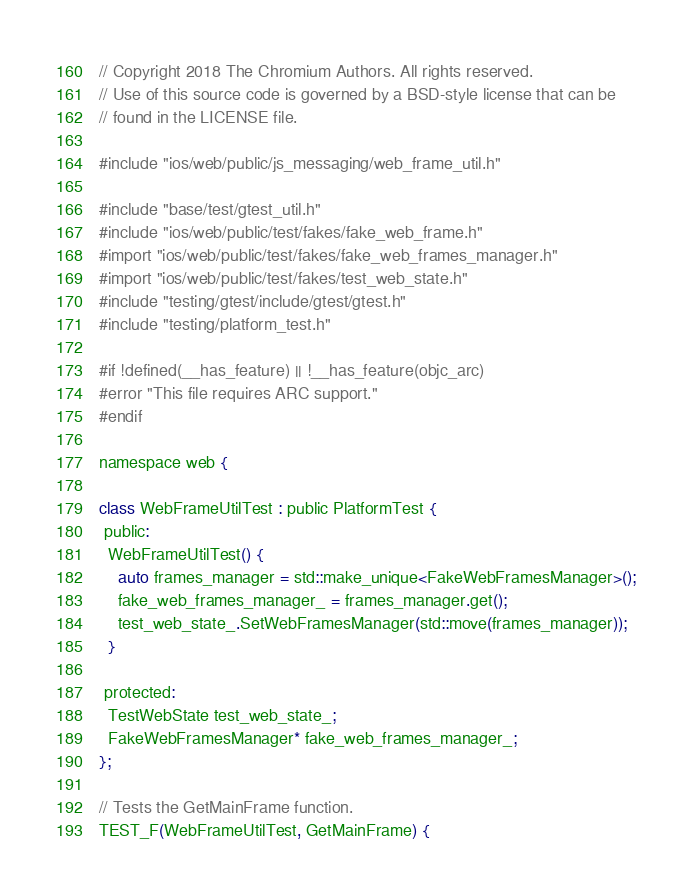Convert code to text. <code><loc_0><loc_0><loc_500><loc_500><_ObjectiveC_>// Copyright 2018 The Chromium Authors. All rights reserved.
// Use of this source code is governed by a BSD-style license that can be
// found in the LICENSE file.

#include "ios/web/public/js_messaging/web_frame_util.h"

#include "base/test/gtest_util.h"
#include "ios/web/public/test/fakes/fake_web_frame.h"
#import "ios/web/public/test/fakes/fake_web_frames_manager.h"
#import "ios/web/public/test/fakes/test_web_state.h"
#include "testing/gtest/include/gtest/gtest.h"
#include "testing/platform_test.h"

#if !defined(__has_feature) || !__has_feature(objc_arc)
#error "This file requires ARC support."
#endif

namespace web {

class WebFrameUtilTest : public PlatformTest {
 public:
  WebFrameUtilTest() {
    auto frames_manager = std::make_unique<FakeWebFramesManager>();
    fake_web_frames_manager_ = frames_manager.get();
    test_web_state_.SetWebFramesManager(std::move(frames_manager));
  }

 protected:
  TestWebState test_web_state_;
  FakeWebFramesManager* fake_web_frames_manager_;
};

// Tests the GetMainFrame function.
TEST_F(WebFrameUtilTest, GetMainFrame) {</code> 